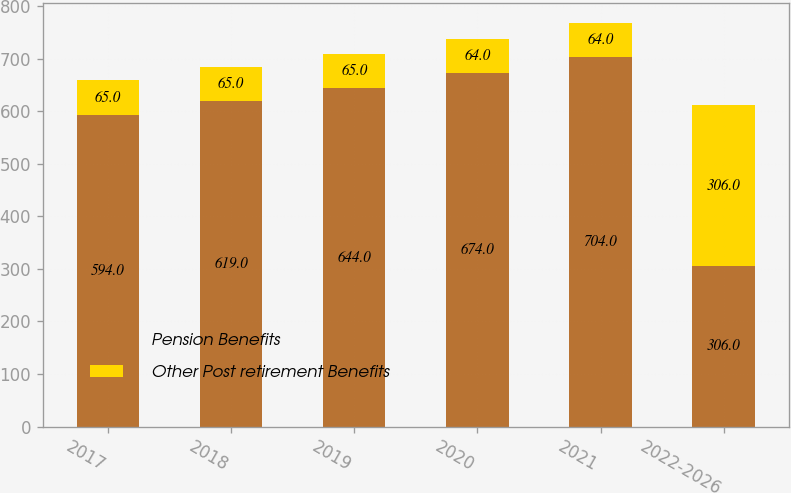<chart> <loc_0><loc_0><loc_500><loc_500><stacked_bar_chart><ecel><fcel>2017<fcel>2018<fcel>2019<fcel>2020<fcel>2021<fcel>2022-2026<nl><fcel>Pension Benefits<fcel>594<fcel>619<fcel>644<fcel>674<fcel>704<fcel>306<nl><fcel>Other Post retirement Benefits<fcel>65<fcel>65<fcel>65<fcel>64<fcel>64<fcel>306<nl></chart> 